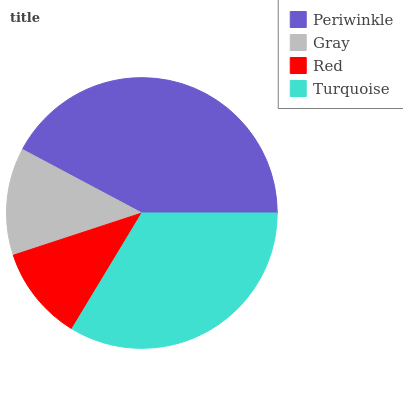Is Red the minimum?
Answer yes or no. Yes. Is Periwinkle the maximum?
Answer yes or no. Yes. Is Gray the minimum?
Answer yes or no. No. Is Gray the maximum?
Answer yes or no. No. Is Periwinkle greater than Gray?
Answer yes or no. Yes. Is Gray less than Periwinkle?
Answer yes or no. Yes. Is Gray greater than Periwinkle?
Answer yes or no. No. Is Periwinkle less than Gray?
Answer yes or no. No. Is Turquoise the high median?
Answer yes or no. Yes. Is Gray the low median?
Answer yes or no. Yes. Is Gray the high median?
Answer yes or no. No. Is Turquoise the low median?
Answer yes or no. No. 